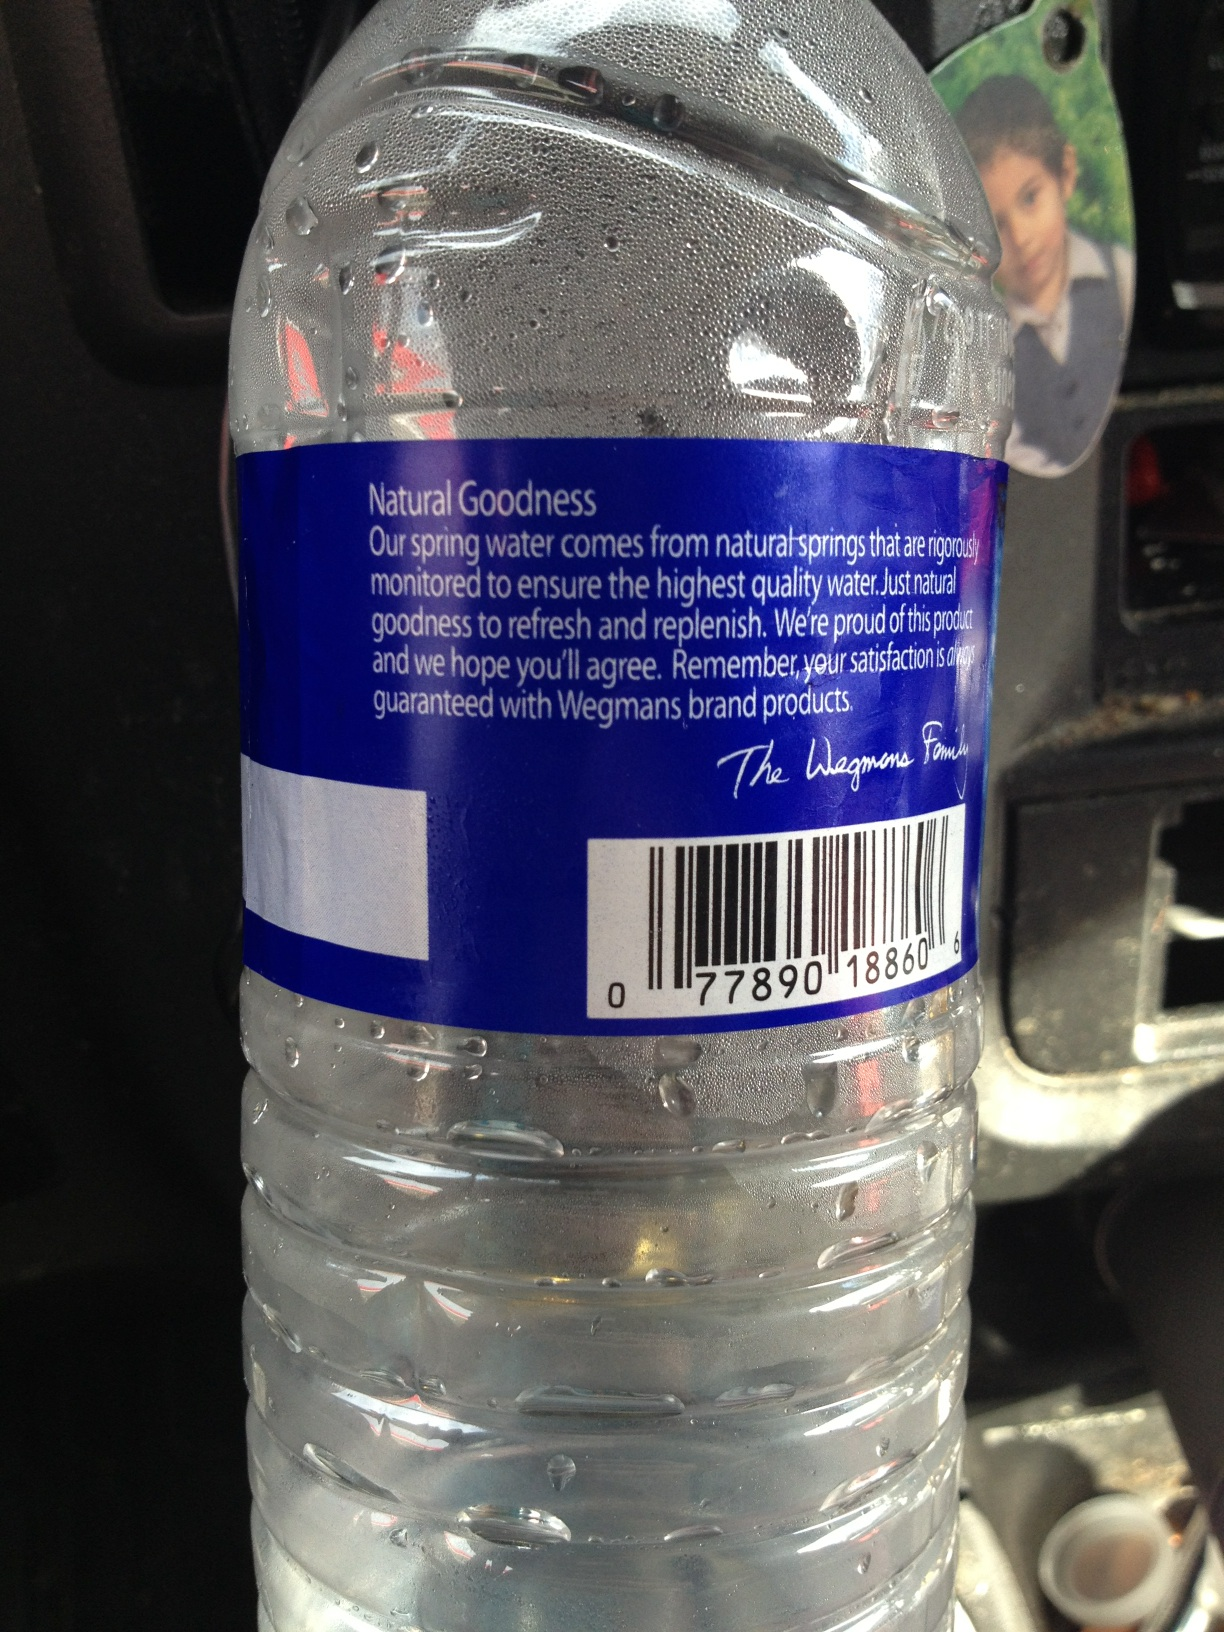What is this? This is a bottle of spring water. The label indicates that it's natural spring water, carefully monitored for high quality. The product is branded under Wegmans, a well-known grocery store chain, and its natural goodness aims to refresh and replenish. 